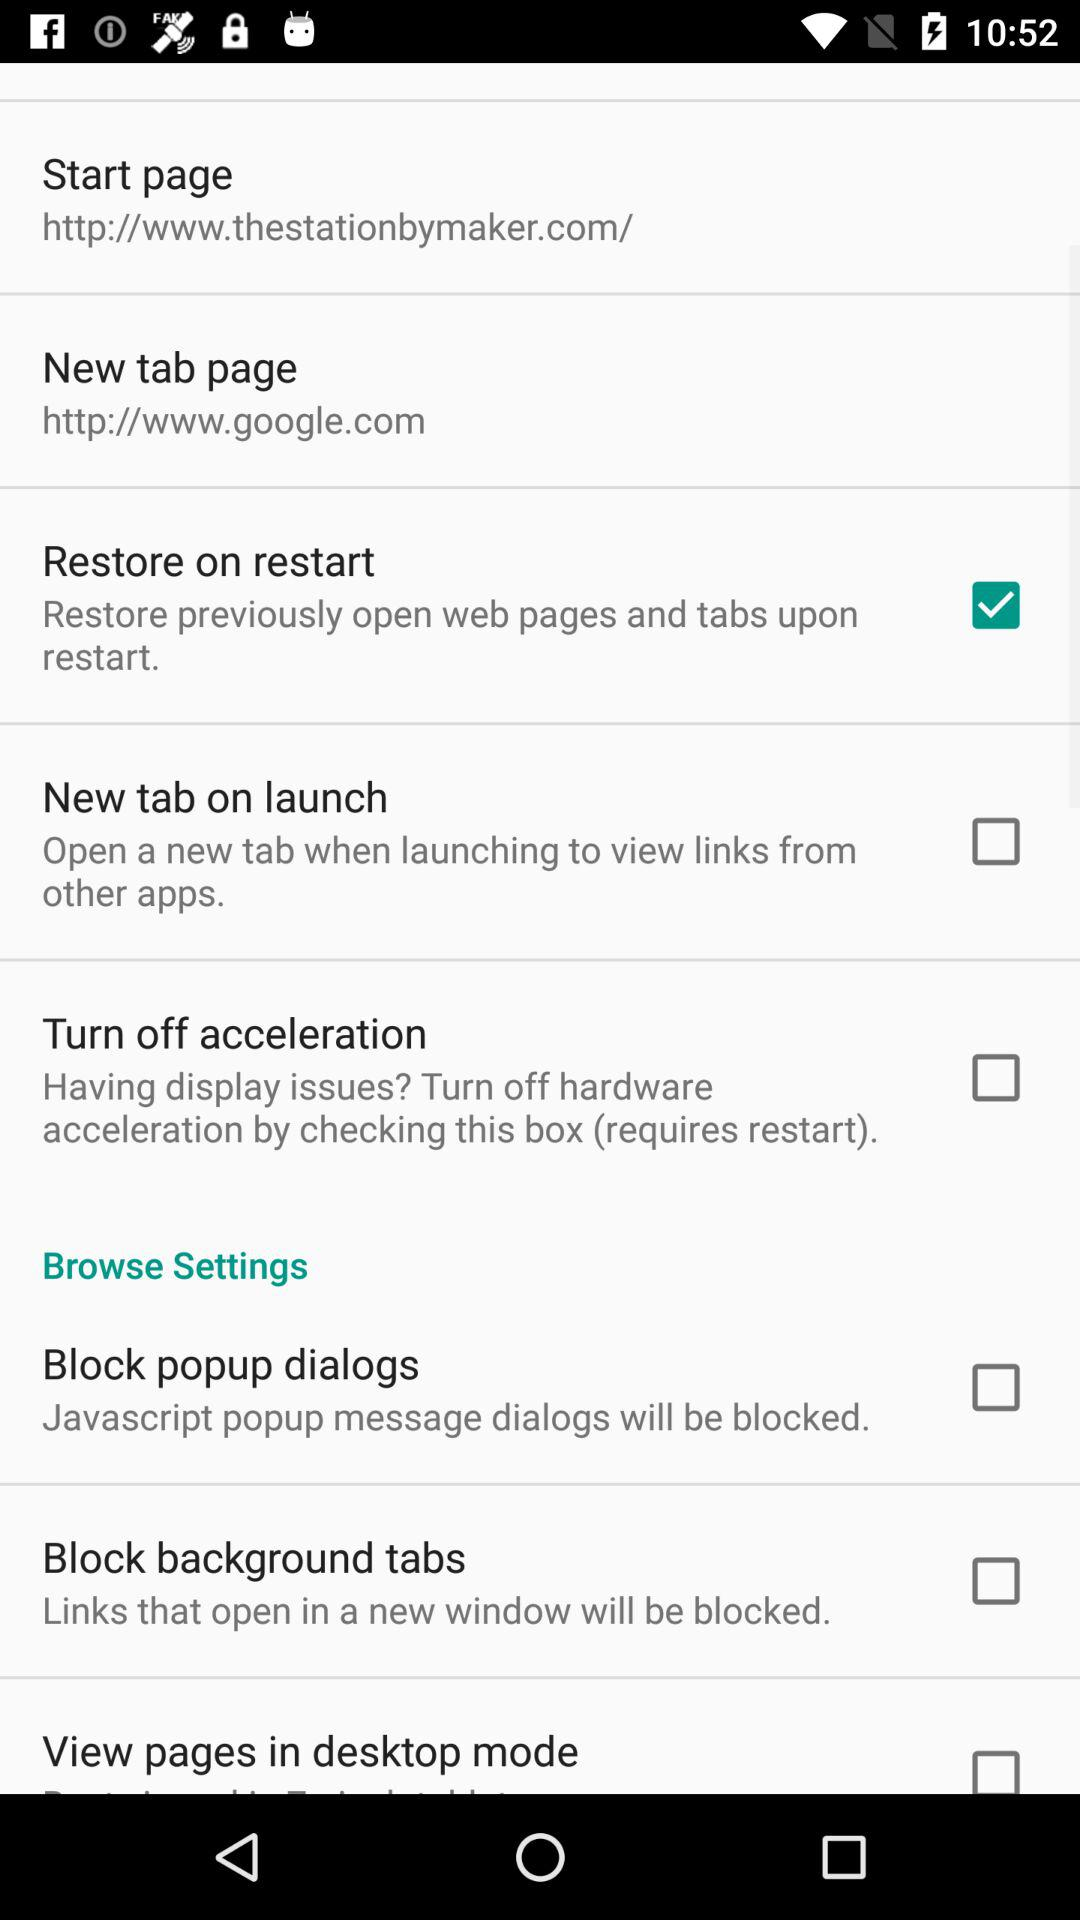What is the status of the restore on restart? The status is on. 